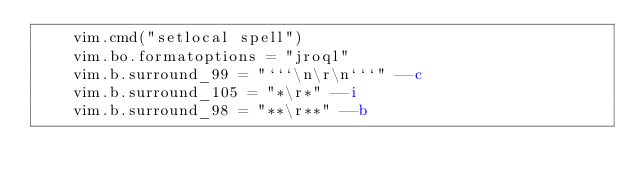Convert code to text. <code><loc_0><loc_0><loc_500><loc_500><_Lua_>	vim.cmd("setlocal spell")
	vim.bo.formatoptions = "jroql"
	vim.b.surround_99 = "```\n\r\n```" --c
	vim.b.surround_105 = "*\r*" --i
	vim.b.surround_98 = "**\r**" --b

</code> 